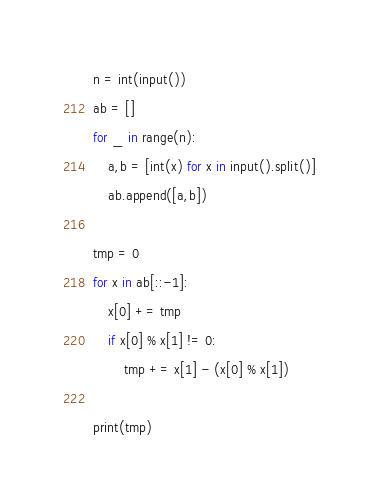Convert code to text. <code><loc_0><loc_0><loc_500><loc_500><_Python_>n = int(input())
ab = []
for _ in range(n):
    a,b = [int(x) for x in input().split()]
    ab.append([a,b])

tmp = 0
for x in ab[::-1]:
    x[0] += tmp
    if x[0] % x[1] != 0: 
        tmp += x[1] - (x[0] % x[1])

print(tmp)</code> 